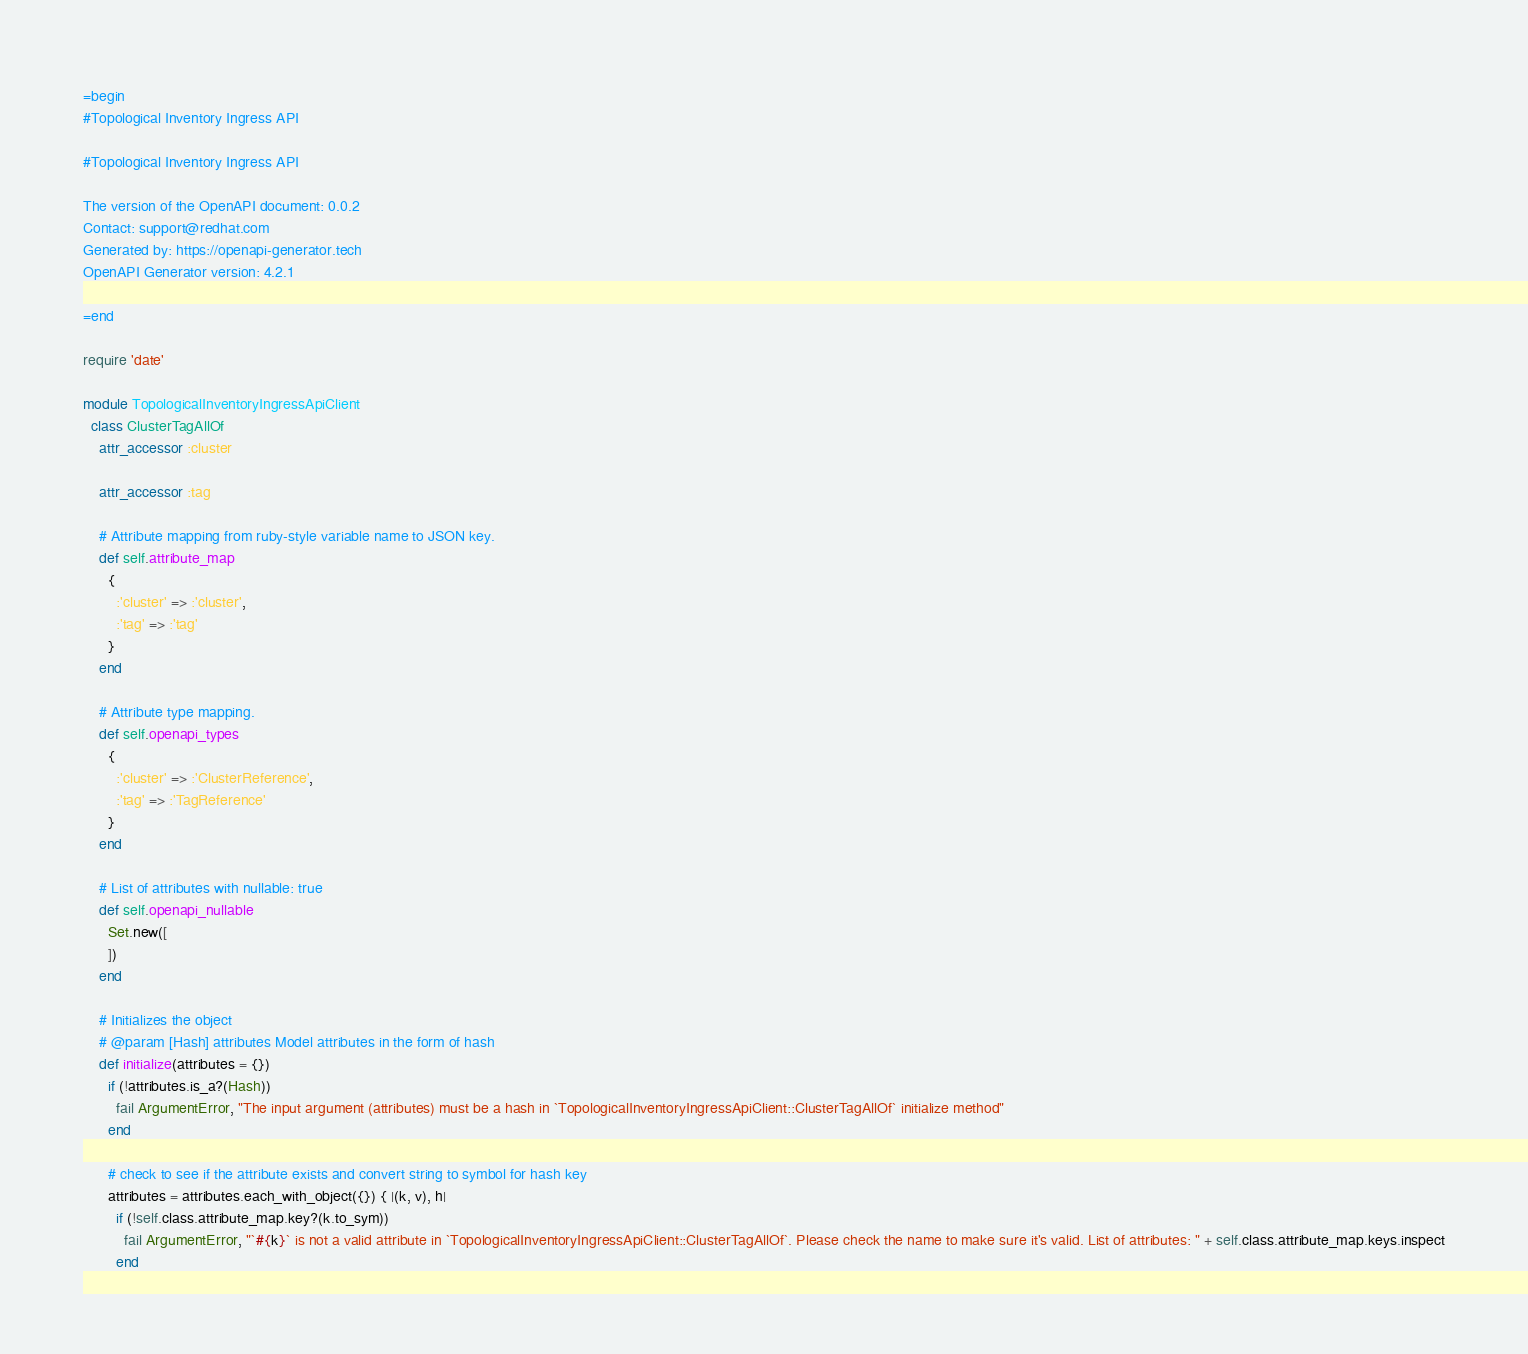Convert code to text. <code><loc_0><loc_0><loc_500><loc_500><_Ruby_>=begin
#Topological Inventory Ingress API

#Topological Inventory Ingress API

The version of the OpenAPI document: 0.0.2
Contact: support@redhat.com
Generated by: https://openapi-generator.tech
OpenAPI Generator version: 4.2.1

=end

require 'date'

module TopologicalInventoryIngressApiClient
  class ClusterTagAllOf
    attr_accessor :cluster

    attr_accessor :tag

    # Attribute mapping from ruby-style variable name to JSON key.
    def self.attribute_map
      {
        :'cluster' => :'cluster',
        :'tag' => :'tag'
      }
    end

    # Attribute type mapping.
    def self.openapi_types
      {
        :'cluster' => :'ClusterReference',
        :'tag' => :'TagReference'
      }
    end

    # List of attributes with nullable: true
    def self.openapi_nullable
      Set.new([
      ])
    end

    # Initializes the object
    # @param [Hash] attributes Model attributes in the form of hash
    def initialize(attributes = {})
      if (!attributes.is_a?(Hash))
        fail ArgumentError, "The input argument (attributes) must be a hash in `TopologicalInventoryIngressApiClient::ClusterTagAllOf` initialize method"
      end

      # check to see if the attribute exists and convert string to symbol for hash key
      attributes = attributes.each_with_object({}) { |(k, v), h|
        if (!self.class.attribute_map.key?(k.to_sym))
          fail ArgumentError, "`#{k}` is not a valid attribute in `TopologicalInventoryIngressApiClient::ClusterTagAllOf`. Please check the name to make sure it's valid. List of attributes: " + self.class.attribute_map.keys.inspect
        end</code> 